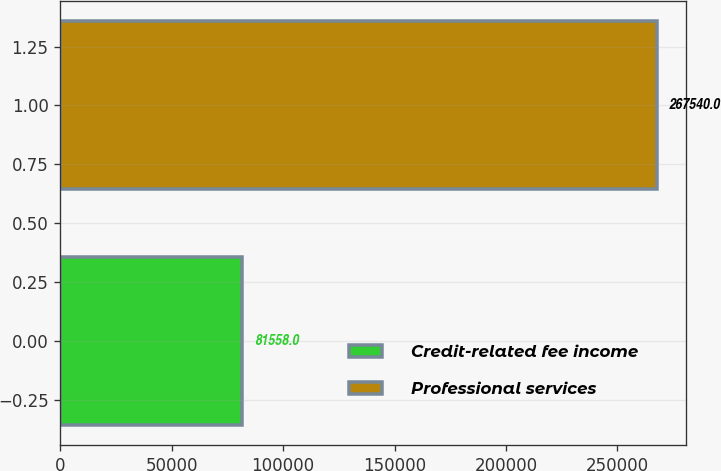Convert chart to OTSL. <chart><loc_0><loc_0><loc_500><loc_500><bar_chart><fcel>Credit-related fee income<fcel>Professional services<nl><fcel>81558<fcel>267540<nl></chart> 